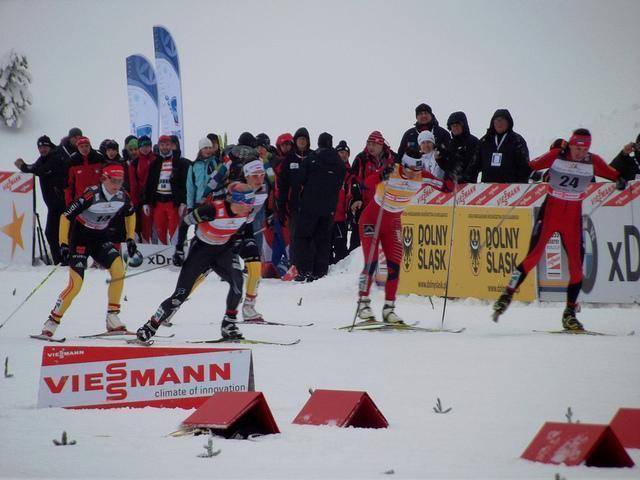How many people are there?
Give a very brief answer. 8. How many red cars are there?
Give a very brief answer. 0. 